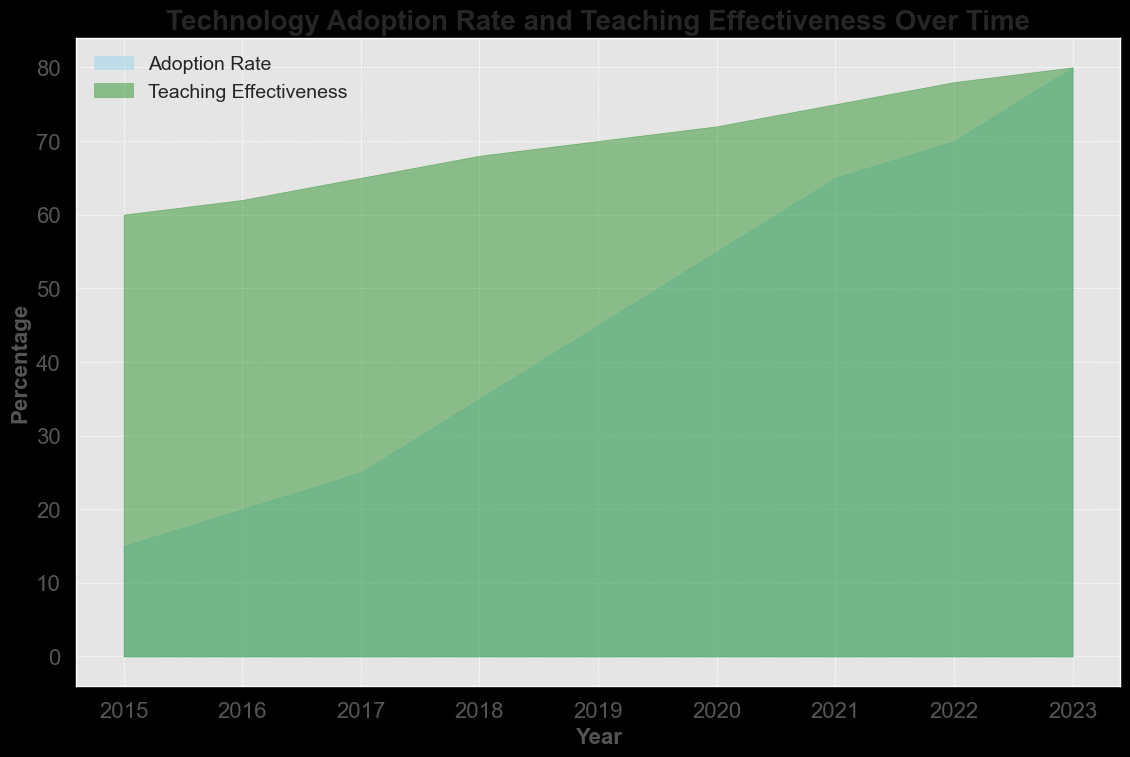What was the technology adoption rate in 2020? According to the chart, the adoption rate for technology in 2020 is indicated by the blue area reaching 55%.
Answer: 55% What was the teaching effectiveness in 2023? By looking at the green area of the chart for the year 2023, it shows a teaching effectiveness of 80%.
Answer: 80% Which year saw the greatest increase in adoption rate compared to the previous year? Looking at the blue area in the chart, the largest increase appears between 2017 and 2018, going from 25% to 35%, a 10% increase.
Answer: 2018 How did teaching effectiveness change from 2019 to 2020? The chart shows teaching effectiveness increasing from 70% in 2019 to 72% in 2020, indicating an increase of 2%.
Answer: Increased by 2% What is the difference between technology adoption rate and teaching effectiveness in 2022? In 2022, the adoption rate is 70% and teaching effectiveness is 78%, resulting in a difference of 78% - 70% = 8%.
Answer: 8% How does the rate of increase in adoption rate from 2015 to 2023 compare to the rate of increase in teaching effectiveness for the same period? The adoption rate increased from 15% in 2015 to 80% in 2023, a difference of 65%. Teaching effectiveness increased from 60% in 2015 to 80% in 2023, a difference of 20%. Therefore, the adoption rate increase is greater at 65% compared to the teaching effectiveness increase of 20%.
Answer: Adoption rate increase is greater In which years did the adoption rate exceed 50%? Referring to the blue area in the chart, the adoption rate exceeded 50% between 2020 and 2023.
Answer: 2020 to 2023 What is the average teaching effectiveness from 2015 to 2023? Summing the teaching effectiveness percentages (60 + 62 + 65 + 68 + 70 + 72 + 75 + 78 + 80) and dividing by the number of years (9), we get (630 / 9 ≈ 70).
Answer: 70 Is there a year where the adoption rate and teaching effectiveness are equal? No year in the chart shows the same value for both adoption rate and teaching effectiveness.
Answer: No What is the total increase in teaching effectiveness from 2016 to 2023? Teaching effectiveness increased from 62% in 2016 to 80% in 2023. The total increase is 80% - 62% = 18%.
Answer: 18% 